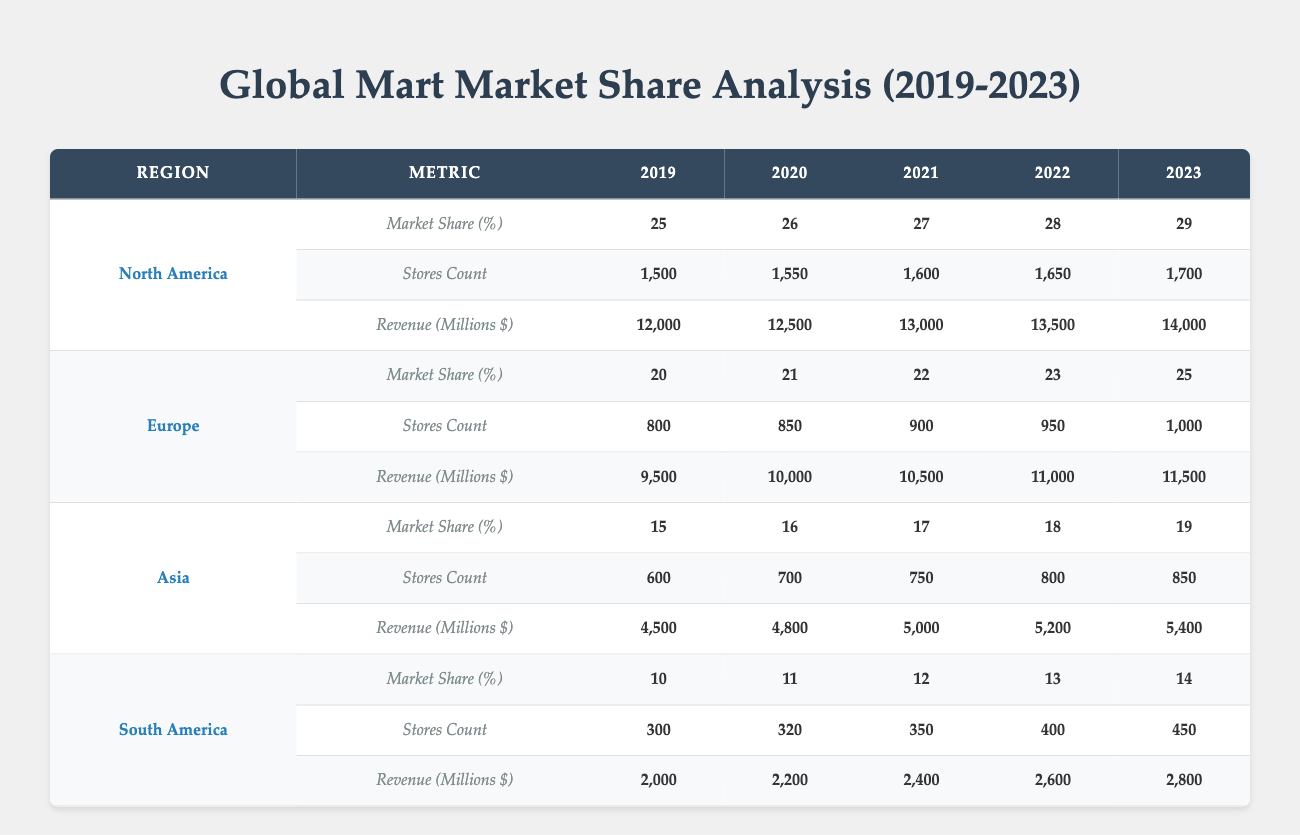What was the market share percentage for Asia in 2021? The market share percentage for Asia in 2021 can be found in the table under the Asia section for the year 2021, which is 17%.
Answer: 17% What is the revenue for South America in 2023? Looking at the South America row for the year 2023, the revenue listed is 2,800 million dollars.
Answer: 2,800 Which region had the highest number of stores in 2022? The stores count for each region in 2022 is: North America (1,650), Europe (950), Asia (800), South America (400). The highest count is for North America with 1,650 stores.
Answer: North America Is the market share for Europe increasing each year? By observing the market share percentages for Europe across all years listed (20, 21, 22, 23, 25), we see a continuous rise, indicating that the market share for Europe is indeed increasing each year.
Answer: Yes What was the average revenue across all regions in 2020? The revenue for each region in 2020 is as follows: North America (12,500), Europe (10,000), Asia (4,800), South America (2,200). Adding these amounts gives 12,500 + 10,000 + 4,800 + 2,200 = 29,500 million dollars. Dividing by the 4 regions gives us 29,500/4 = 7,375 million dollars as the average.
Answer: 7,375 What is the percentage increase in market share for North America from 2019 to 2023? The market share for North America in 2019 was 25% and in 2023 was 29%. The increase is calculated as (29 - 25) = 4%. To find the percentage increase, we apply (4/25) * 100% = 16%.
Answer: 16% Which region had the least revenue in 2020? In 2020, we can see the revenue values: North America (12,500), Europe (10,000), Asia (4,800), South America (2,200). The lowest revenue is for South America with 2,200 million dollars.
Answer: South America How many stores did Europe have in 2023 compared to 2019? In the year 2023, Europe had 1,000 stores, while in 2019 it had 800 stores. The difference is 1,000 - 800 = 200 additional stores.
Answer: 200 Which region has the lowest market share in 2022? The market share findings for each region in 2022 are: North America (28%), Europe (23%), Asia (18%), and South America (13%). South America has the lowest market share at 13%.
Answer: South America 